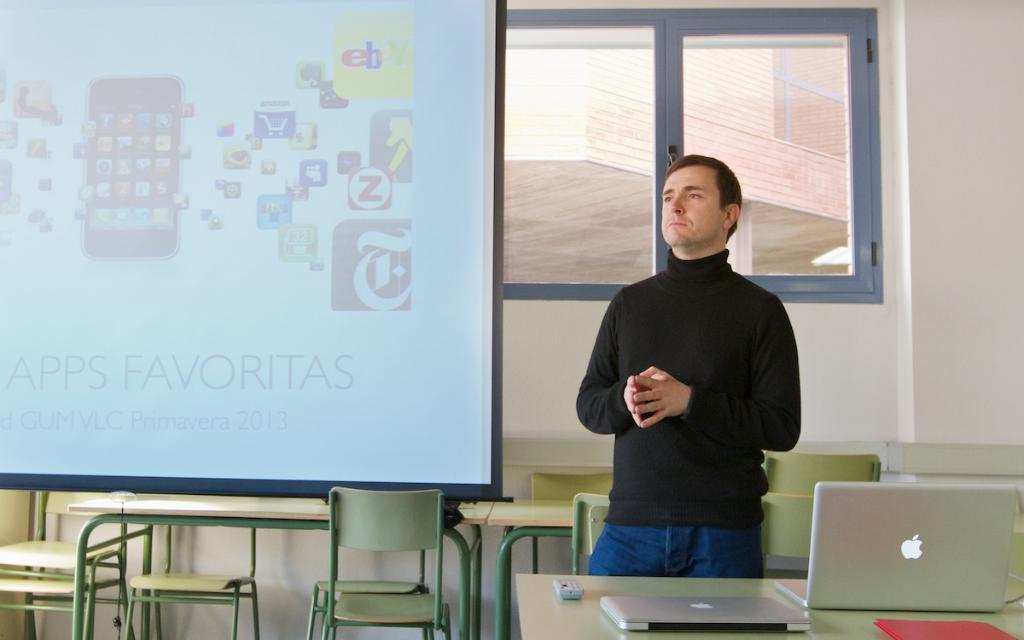Can you describe this image briefly? In this picture there is a man standing, he has a laptop in front of him and in the background there is a projector screen 